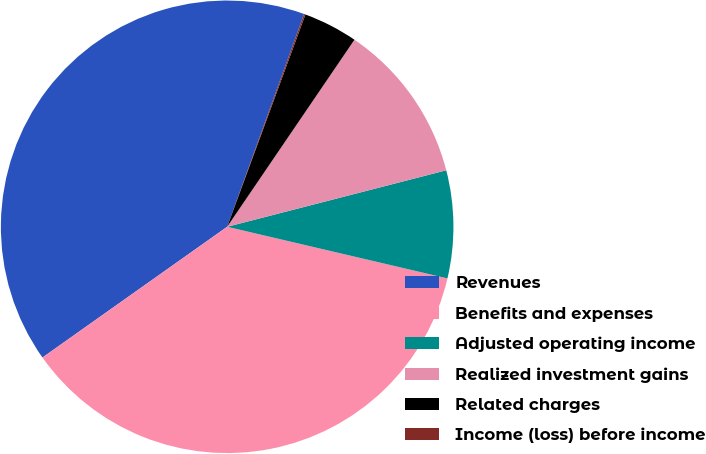Convert chart to OTSL. <chart><loc_0><loc_0><loc_500><loc_500><pie_chart><fcel>Revenues<fcel>Benefits and expenses<fcel>Adjusted operating income<fcel>Realized investment gains<fcel>Related charges<fcel>Income (loss) before income<nl><fcel>40.32%<fcel>36.53%<fcel>7.68%<fcel>11.47%<fcel>3.89%<fcel>0.1%<nl></chart> 